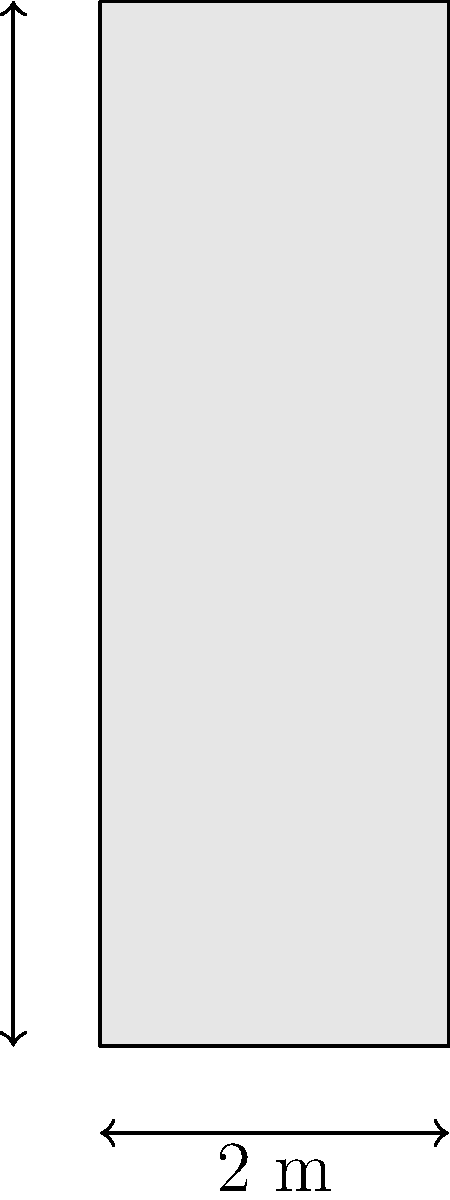As a future museum curator, you're tasked with estimating the surface area of an ancient Greek cylindrical column for a new exhibit. The column has a height of 6 meters and a diameter of 2 meters. Assuming the column is a perfect cylinder without a base or top, what is its approximate surface area? (Use $\pi \approx 3.14$) To calculate the surface area of a cylindrical column without a base or top, we need to use the formula for the lateral surface area of a cylinder:

$$ A = 2\pi rh $$

Where:
- $A$ is the surface area
- $r$ is the radius of the base
- $h$ is the height of the cylinder

Given:
- Height (h) = 6 meters
- Diameter = 2 meters

Step 1: Calculate the radius
The radius is half the diameter:
$$ r = 2 \div 2 = 1 \text{ meter} $$

Step 2: Apply the formula
$$ A = 2\pi rh $$
$$ A = 2 \times 3.14 \times 1 \times 6 $$

Step 3: Calculate the result
$$ A = 37.68 \text{ square meters} $$

Therefore, the approximate surface area of the ancient Greek column is 37.68 square meters.
Answer: 37.68 m² 